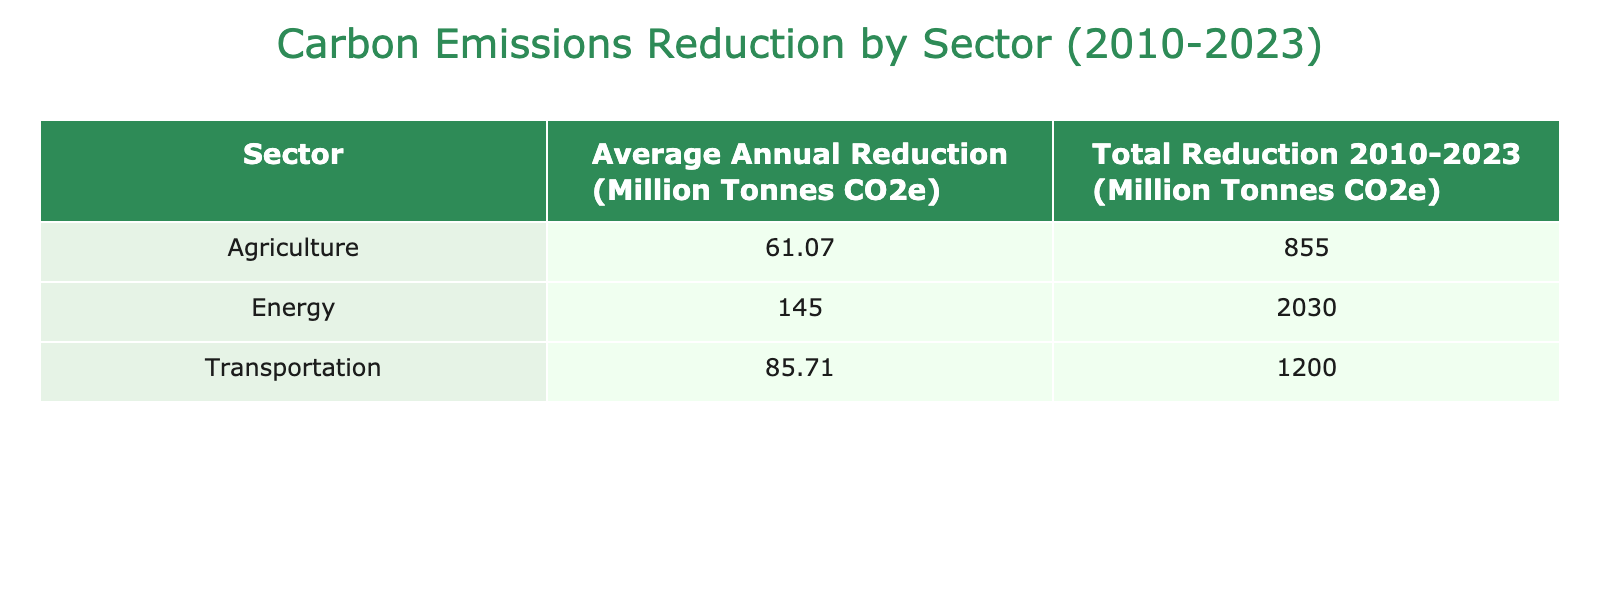What is the total carbon emissions reduction for the Energy sector? To find the total reduction for the Energy sector, we look at the corresponding value in the table. By summing the annual reductions from 2010 to 2023, we see 80 + 90 + 100 + 110 + 120 + 130 + 140 + 150 + 160 + 170 + 180 + 190 + 200 + 210 = 1800 million tonnes CO2e.
Answer: 1800 million tonnes CO2e Which sector has the highest average annual carbon emissions reduction? To determine which sector has the highest average, we calculate the average for each sector: Energy (1800/14 = 128.57), Transportation (1350/14 = 96.43), and Agriculture (880/14 = 62.86). Energy, with an average of 128.57 million tonnes CO2e, is the highest.
Answer: Energy What is the total carbon emissions reduction from Agriculture between 2010 and 2023? We sum the annual reductions specifically for the Agriculture sector: 25 + 30 + 35 + 40 + 50 + 55 + 60 + 65 + 70 + 75 + 80 + 85 + 90 + 95 = 835 million tonnes CO2e.
Answer: 835 million tonnes CO2e Is the average annual carbon emissions reduction for Transportation greater than that of Agriculture? Calculating the averages, Transportation is (1350/14 = 96.43) and Agriculture is (880/14 = 62.86). Since 96.43 is greater than 62.86, the statement is true.
Answer: Yes What is the difference in total carbon emissions reduction between the Energy and Agriculture sectors? We calculated the totals earlier: Energy total is 1800 million tonnes CO2e, and Agriculture is 835 million tonnes CO2e. The difference is 1800 - 835 = 965 million tonnes CO2e.
Answer: 965 million tonnes CO2e 